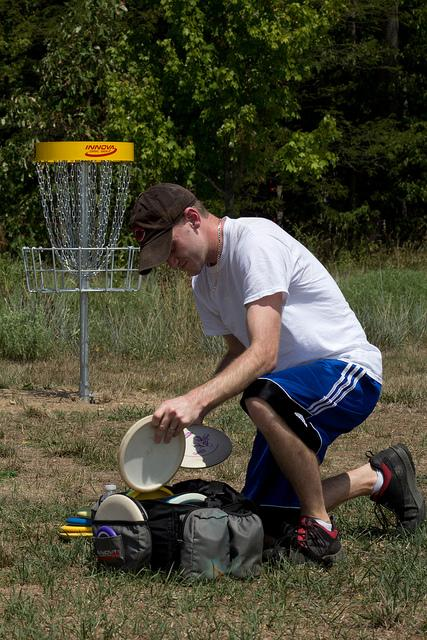The man has what on his head?

Choices:
A) umbrella
B) bonnet
C) helmet
D) cap cap 